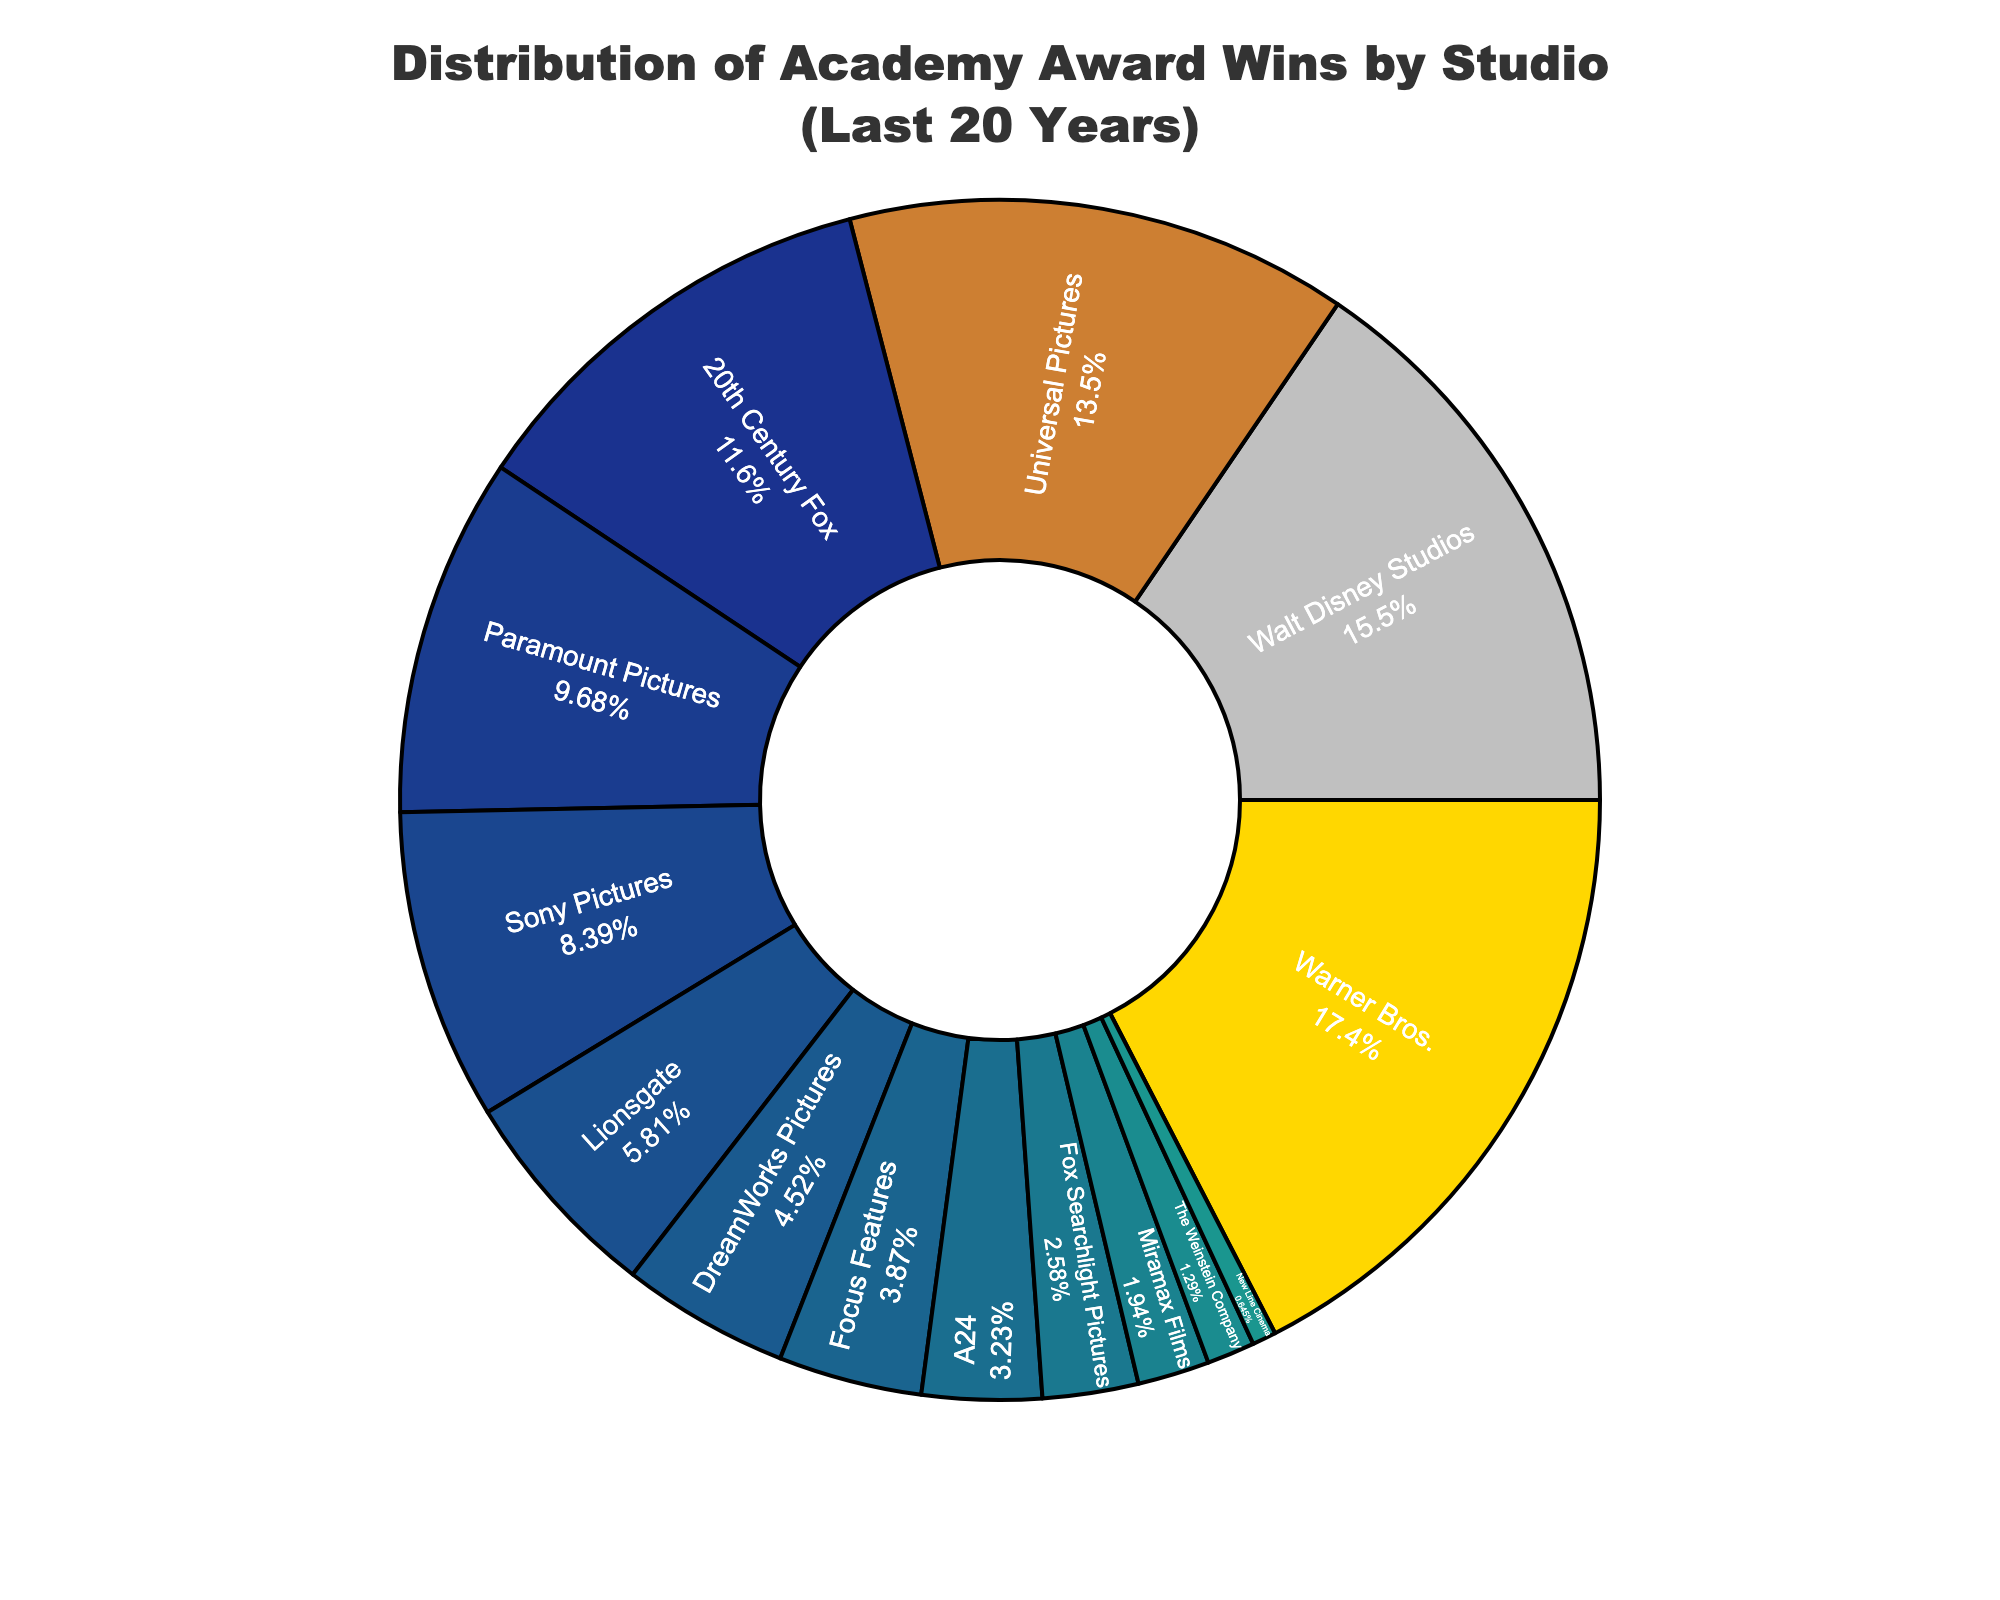Which studio has won the most Academy Awards in the past 20 years? Warner Bros. has the largest segment in the pie chart, indicating that it has won the most Academy Awards.
Answer: Warner Bros Which two studios have the smallest share of Academy Awards wins, and how many have they won in total? New Line Cinema and The Weinstein Company have the smallest segments. They have won 1 and 2 awards respectively; together they have won 1 + 2 = 3 awards.
Answer: New Line Cinema and The Weinstein Company, 3 Which studio has more Academy Award wins, Walt Disney Studios or Universal Pictures, and by how many? Walt Disney Studios has 24 wins, and Universal Pictures has 21 wins. The difference between their wins is 24 - 21 = 3.
Answer: Walt Disney Studios, 3 What percentage of the total Academy Award wins does Sony Pictures have? Sony Pictures' segment shows its percentage. To calculate, note Sony Pictures has 13 awards. The total is 27 + 24 + 21 + 18 + 15 + 13 + 9 + 7 + 6 + 5 + 4 + 3 + 2 + 1 = 155. So, the percentage is (13 / 155) * 100 which is approximately 8.39%.
Answer: 8.39% How many more Academy Awards has Warner Bros. won compared to Paramount Pictures? Warner Bros. has 27 awards, and Paramount Pictures has 15. The difference is 27 - 15 = 12.
Answer: 12 What's the median number of Academy Award wins among all these studios? To find the median, list the wins in ascending order: 1, 2, 3, 4, 5, 6, 7, 9, 13, 15, 18, 21, 24, 27. There are 14 studios, so the median is the average of the 7th and 8th values. The 7th and 8th values are 9 and 13, respectively. The median is (9 + 13) / 2 = 11.
Answer: 11 Which studio has the third largest share of Academy Award wins? The third largest segment in the pie chart belongs to Universal Pictures.
Answer: Universal Pictures If we combine the Academy Award wins of DreamWorks Pictures and Focus Features, how does their total compare to Sony Pictures' wins? DreamWorks Pictures has 7 wins and Focus Features has 6 wins. Together, they have 7 + 6 = 13 wins, which is equal to Sony Pictures' 13 wins.
Answer: Equal What fraction of the total Academy Award wins is attributed to 20th Century Fox? 20th Century Fox has 18 wins. The total number of wins is 155. Therefore, the fraction is 18 / 155, which simplifies to approximately 9/78, further simplified, is about 2/17.
Answer: 2/17 Which studios have a share under 5% of the total Academy Award wins, and how many studios are there in total? Studios with less than 5% are A24, Fox Searchlight Pictures, Miramax Films, The Weinstein Company, and New Line Cinema. The total number of studios is 14.
Answer: A24, Fox Searchlight Pictures, Miramax Films, The Weinstein Company, New Line Cinema; 14 